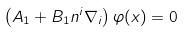<formula> <loc_0><loc_0><loc_500><loc_500>\left ( A _ { 1 } + B _ { 1 } n ^ { i } \nabla _ { i } \right ) \varphi ( x ) = 0</formula> 